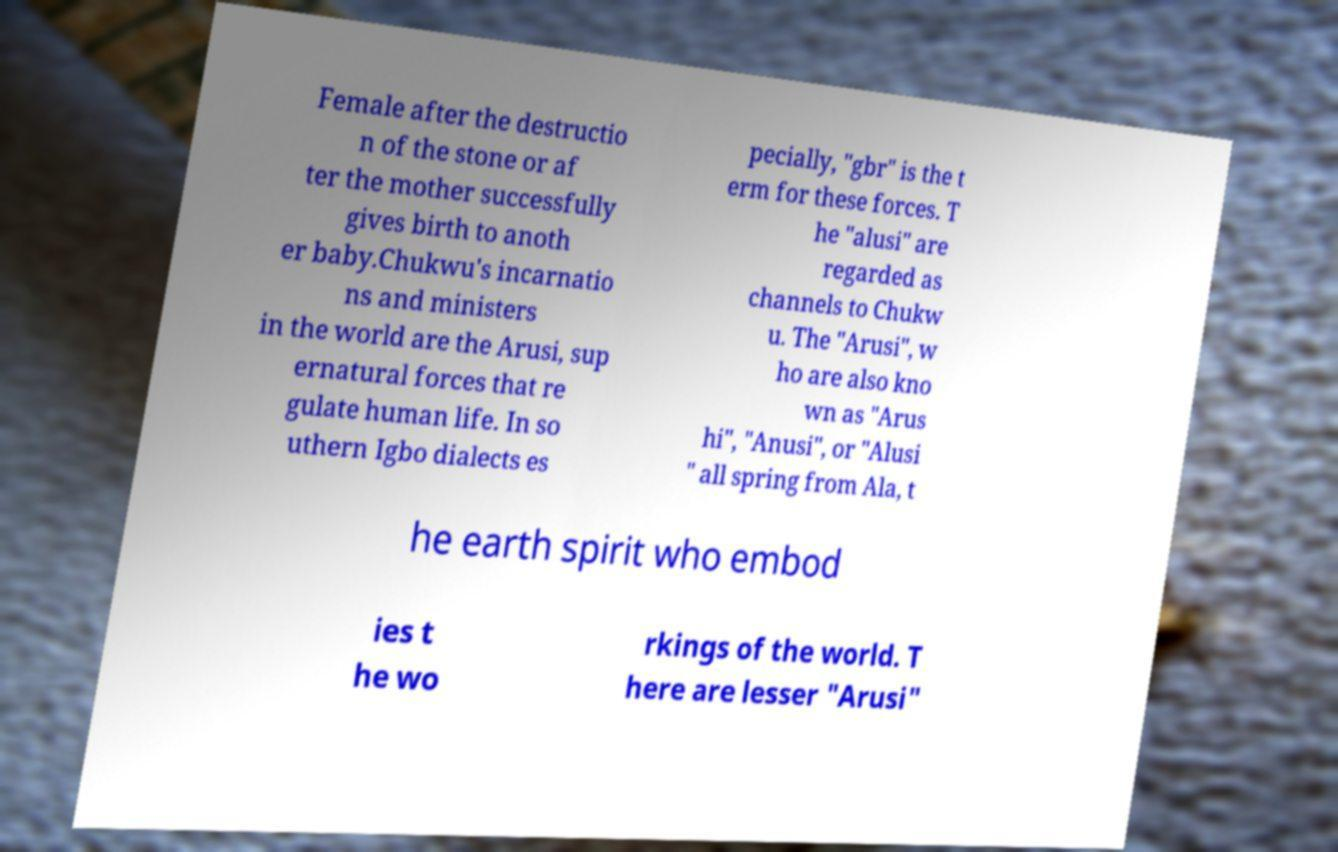Could you assist in decoding the text presented in this image and type it out clearly? Female after the destructio n of the stone or af ter the mother successfully gives birth to anoth er baby.Chukwu's incarnatio ns and ministers in the world are the Arusi, sup ernatural forces that re gulate human life. In so uthern Igbo dialects es pecially, "gbr" is the t erm for these forces. T he "alusi" are regarded as channels to Chukw u. The "Arusi", w ho are also kno wn as "Arus hi", "Anusi", or "Alusi " all spring from Ala, t he earth spirit who embod ies t he wo rkings of the world. T here are lesser "Arusi" 